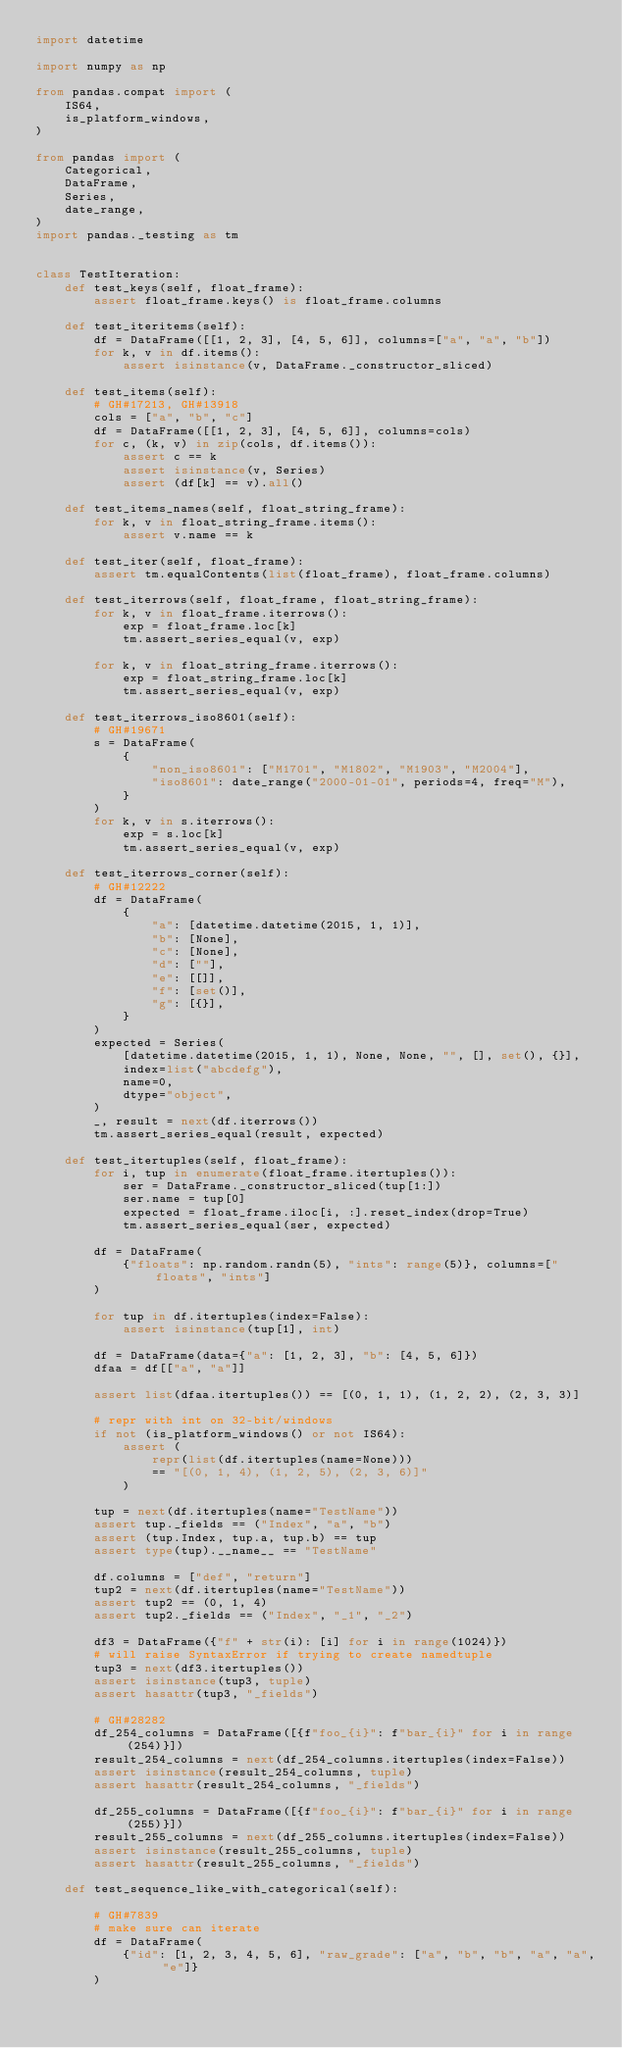Convert code to text. <code><loc_0><loc_0><loc_500><loc_500><_Python_>import datetime

import numpy as np

from pandas.compat import (
    IS64,
    is_platform_windows,
)

from pandas import (
    Categorical,
    DataFrame,
    Series,
    date_range,
)
import pandas._testing as tm


class TestIteration:
    def test_keys(self, float_frame):
        assert float_frame.keys() is float_frame.columns

    def test_iteritems(self):
        df = DataFrame([[1, 2, 3], [4, 5, 6]], columns=["a", "a", "b"])
        for k, v in df.items():
            assert isinstance(v, DataFrame._constructor_sliced)

    def test_items(self):
        # GH#17213, GH#13918
        cols = ["a", "b", "c"]
        df = DataFrame([[1, 2, 3], [4, 5, 6]], columns=cols)
        for c, (k, v) in zip(cols, df.items()):
            assert c == k
            assert isinstance(v, Series)
            assert (df[k] == v).all()

    def test_items_names(self, float_string_frame):
        for k, v in float_string_frame.items():
            assert v.name == k

    def test_iter(self, float_frame):
        assert tm.equalContents(list(float_frame), float_frame.columns)

    def test_iterrows(self, float_frame, float_string_frame):
        for k, v in float_frame.iterrows():
            exp = float_frame.loc[k]
            tm.assert_series_equal(v, exp)

        for k, v in float_string_frame.iterrows():
            exp = float_string_frame.loc[k]
            tm.assert_series_equal(v, exp)

    def test_iterrows_iso8601(self):
        # GH#19671
        s = DataFrame(
            {
                "non_iso8601": ["M1701", "M1802", "M1903", "M2004"],
                "iso8601": date_range("2000-01-01", periods=4, freq="M"),
            }
        )
        for k, v in s.iterrows():
            exp = s.loc[k]
            tm.assert_series_equal(v, exp)

    def test_iterrows_corner(self):
        # GH#12222
        df = DataFrame(
            {
                "a": [datetime.datetime(2015, 1, 1)],
                "b": [None],
                "c": [None],
                "d": [""],
                "e": [[]],
                "f": [set()],
                "g": [{}],
            }
        )
        expected = Series(
            [datetime.datetime(2015, 1, 1), None, None, "", [], set(), {}],
            index=list("abcdefg"),
            name=0,
            dtype="object",
        )
        _, result = next(df.iterrows())
        tm.assert_series_equal(result, expected)

    def test_itertuples(self, float_frame):
        for i, tup in enumerate(float_frame.itertuples()):
            ser = DataFrame._constructor_sliced(tup[1:])
            ser.name = tup[0]
            expected = float_frame.iloc[i, :].reset_index(drop=True)
            tm.assert_series_equal(ser, expected)

        df = DataFrame(
            {"floats": np.random.randn(5), "ints": range(5)}, columns=["floats", "ints"]
        )

        for tup in df.itertuples(index=False):
            assert isinstance(tup[1], int)

        df = DataFrame(data={"a": [1, 2, 3], "b": [4, 5, 6]})
        dfaa = df[["a", "a"]]

        assert list(dfaa.itertuples()) == [(0, 1, 1), (1, 2, 2), (2, 3, 3)]

        # repr with int on 32-bit/windows
        if not (is_platform_windows() or not IS64):
            assert (
                repr(list(df.itertuples(name=None)))
                == "[(0, 1, 4), (1, 2, 5), (2, 3, 6)]"
            )

        tup = next(df.itertuples(name="TestName"))
        assert tup._fields == ("Index", "a", "b")
        assert (tup.Index, tup.a, tup.b) == tup
        assert type(tup).__name__ == "TestName"

        df.columns = ["def", "return"]
        tup2 = next(df.itertuples(name="TestName"))
        assert tup2 == (0, 1, 4)
        assert tup2._fields == ("Index", "_1", "_2")

        df3 = DataFrame({"f" + str(i): [i] for i in range(1024)})
        # will raise SyntaxError if trying to create namedtuple
        tup3 = next(df3.itertuples())
        assert isinstance(tup3, tuple)
        assert hasattr(tup3, "_fields")

        # GH#28282
        df_254_columns = DataFrame([{f"foo_{i}": f"bar_{i}" for i in range(254)}])
        result_254_columns = next(df_254_columns.itertuples(index=False))
        assert isinstance(result_254_columns, tuple)
        assert hasattr(result_254_columns, "_fields")

        df_255_columns = DataFrame([{f"foo_{i}": f"bar_{i}" for i in range(255)}])
        result_255_columns = next(df_255_columns.itertuples(index=False))
        assert isinstance(result_255_columns, tuple)
        assert hasattr(result_255_columns, "_fields")

    def test_sequence_like_with_categorical(self):

        # GH#7839
        # make sure can iterate
        df = DataFrame(
            {"id": [1, 2, 3, 4, 5, 6], "raw_grade": ["a", "b", "b", "a", "a", "e"]}
        )</code> 